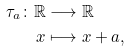<formula> <loc_0><loc_0><loc_500><loc_500>\tau _ { a } \colon \mathbb { R } & \longrightarrow \mathbb { R } \\ x & \longmapsto x + a ,</formula> 